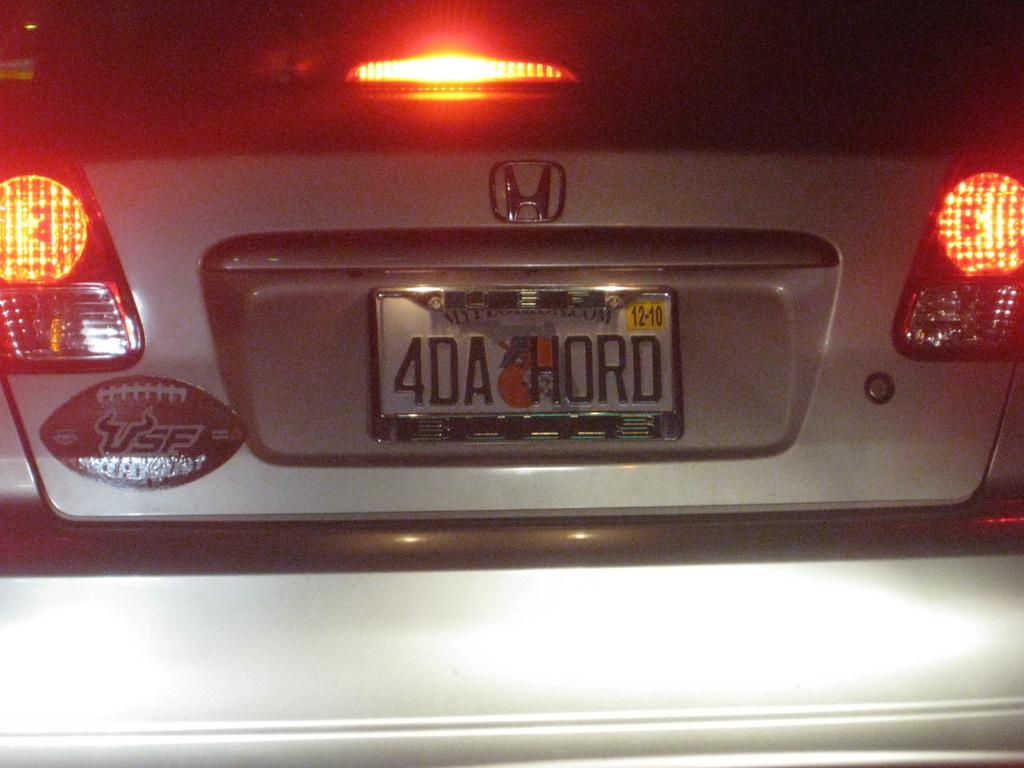What is the license plate name?
Provide a succinct answer. 4da hord. What are the license plate numbers/?
Make the answer very short. 4da hord. 